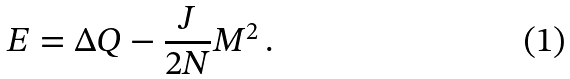<formula> <loc_0><loc_0><loc_500><loc_500>E = \Delta Q - \frac { J } { 2 N } M ^ { 2 } \, .</formula> 